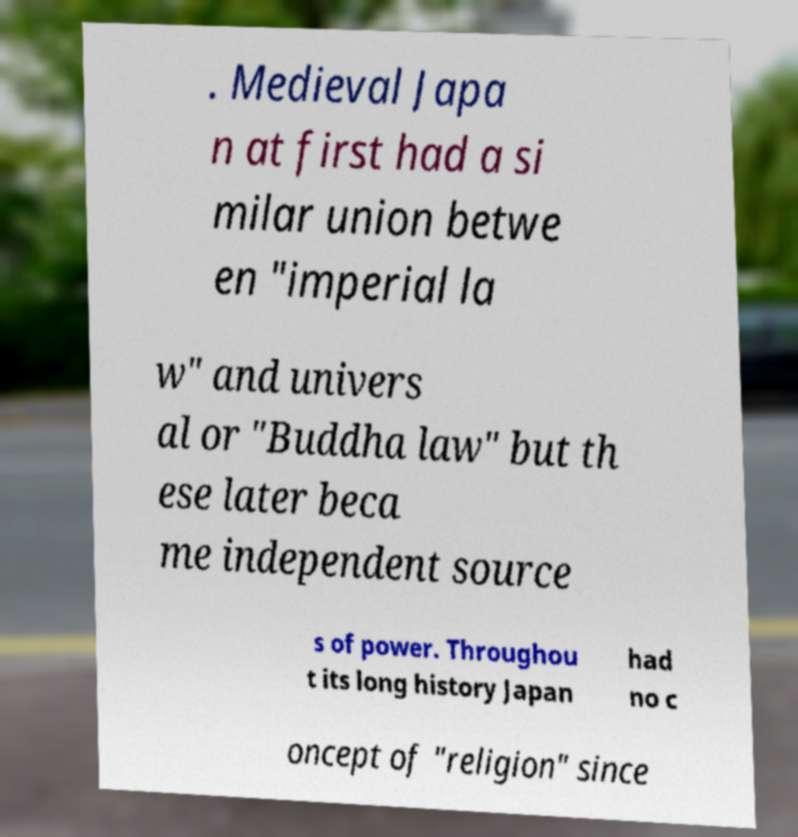Can you read and provide the text displayed in the image?This photo seems to have some interesting text. Can you extract and type it out for me? . Medieval Japa n at first had a si milar union betwe en "imperial la w" and univers al or "Buddha law" but th ese later beca me independent source s of power. Throughou t its long history Japan had no c oncept of "religion" since 